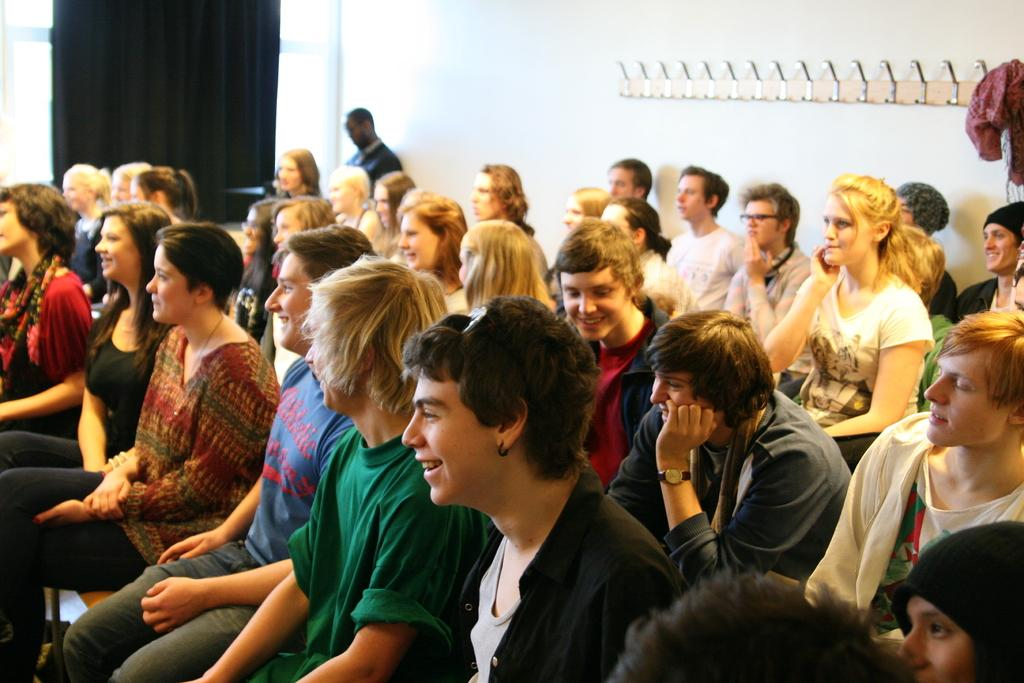What are the people in the image doing? There is a group of people sitting in the image. What can be seen hanging in the image? There is a cloth on a hanger in the image. What type of structure is visible in the image? There is a wall in the image. What is associated with the window in the image? There is a curtain associated with a window in the image. Can you describe the window in the image? There is a window in the image. What type of marble is visible on the floor in the image? There is no marble visible on the floor in the image. What type of scarecrow can be seen standing in the corner of the room in the image? There is no scarecrow present in the image. 